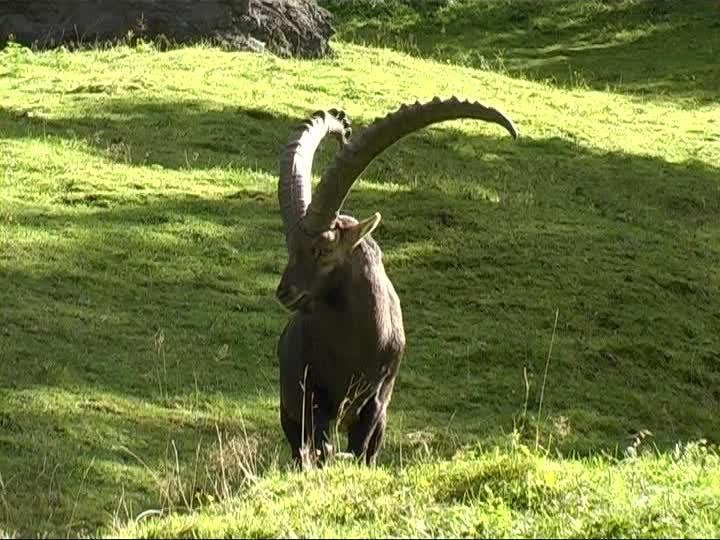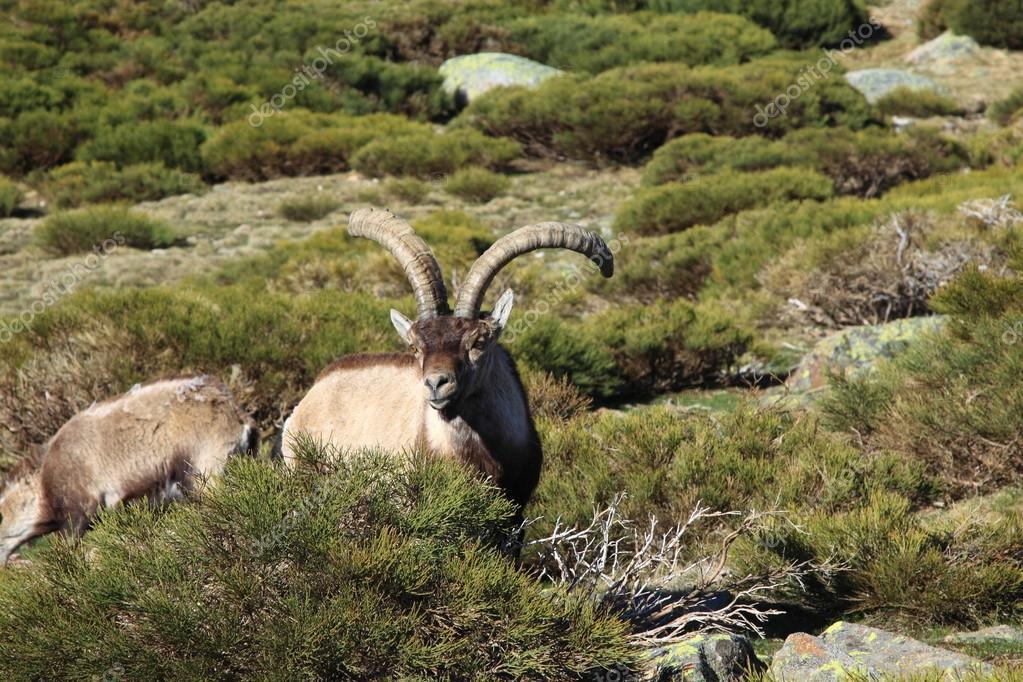The first image is the image on the left, the second image is the image on the right. Given the left and right images, does the statement "An animal sits atop a rocky outcropping in the image on the right." hold true? Answer yes or no. No. 